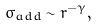<formula> <loc_0><loc_0><loc_500><loc_500>\sigma _ { a d d } \sim r ^ { - \gamma } ,</formula> 